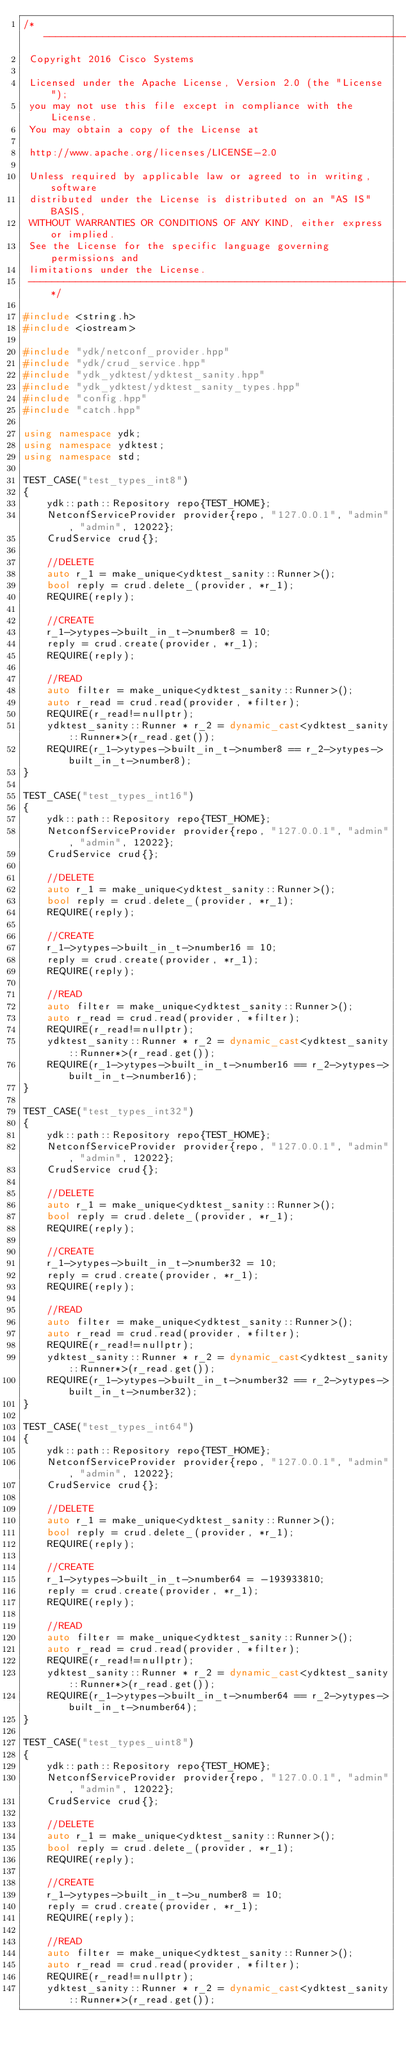Convert code to text. <code><loc_0><loc_0><loc_500><loc_500><_C++_>/*  ----------------------------------------------------------------
 Copyright 2016 Cisco Systems

 Licensed under the Apache License, Version 2.0 (the "License");
 you may not use this file except in compliance with the License.
 You may obtain a copy of the License at

 http://www.apache.org/licenses/LICENSE-2.0

 Unless required by applicable law or agreed to in writing, software
 distributed under the License is distributed on an "AS IS" BASIS,
 WITHOUT WARRANTIES OR CONDITIONS OF ANY KIND, either express or implied.
 See the License for the specific language governing permissions and
 limitations under the License.
 ------------------------------------------------------------------*/

#include <string.h>
#include <iostream>

#include "ydk/netconf_provider.hpp"
#include "ydk/crud_service.hpp"
#include "ydk_ydktest/ydktest_sanity.hpp"
#include "ydk_ydktest/ydktest_sanity_types.hpp"
#include "config.hpp"
#include "catch.hpp"

using namespace ydk;
using namespace ydktest;
using namespace std;

TEST_CASE("test_types_int8")
{
    ydk::path::Repository repo{TEST_HOME};
    NetconfServiceProvider provider{repo, "127.0.0.1", "admin", "admin", 12022};
    CrudService crud{};

    //DELETE
    auto r_1 = make_unique<ydktest_sanity::Runner>();
    bool reply = crud.delete_(provider, *r_1);
    REQUIRE(reply);

    //CREATE
    r_1->ytypes->built_in_t->number8 = 10;
    reply = crud.create(provider, *r_1);
    REQUIRE(reply);

    //READ
    auto filter = make_unique<ydktest_sanity::Runner>();
    auto r_read = crud.read(provider, *filter);
    REQUIRE(r_read!=nullptr);
    ydktest_sanity::Runner * r_2 = dynamic_cast<ydktest_sanity::Runner*>(r_read.get());
    REQUIRE(r_1->ytypes->built_in_t->number8 == r_2->ytypes->built_in_t->number8);
}

TEST_CASE("test_types_int16")
{
    ydk::path::Repository repo{TEST_HOME};
    NetconfServiceProvider provider{repo, "127.0.0.1", "admin", "admin", 12022};
    CrudService crud{};

    //DELETE
    auto r_1 = make_unique<ydktest_sanity::Runner>();
    bool reply = crud.delete_(provider, *r_1);
    REQUIRE(reply);

    //CREATE
    r_1->ytypes->built_in_t->number16 = 10;
    reply = crud.create(provider, *r_1);
    REQUIRE(reply);

    //READ
    auto filter = make_unique<ydktest_sanity::Runner>();
    auto r_read = crud.read(provider, *filter);
    REQUIRE(r_read!=nullptr);
    ydktest_sanity::Runner * r_2 = dynamic_cast<ydktest_sanity::Runner*>(r_read.get());
    REQUIRE(r_1->ytypes->built_in_t->number16 == r_2->ytypes->built_in_t->number16);
}

TEST_CASE("test_types_int32")
{
    ydk::path::Repository repo{TEST_HOME};
    NetconfServiceProvider provider{repo, "127.0.0.1", "admin", "admin", 12022};
    CrudService crud{};

    //DELETE
    auto r_1 = make_unique<ydktest_sanity::Runner>();
    bool reply = crud.delete_(provider, *r_1);
    REQUIRE(reply);

    //CREATE
    r_1->ytypes->built_in_t->number32 = 10;
    reply = crud.create(provider, *r_1);
    REQUIRE(reply);

    //READ
    auto filter = make_unique<ydktest_sanity::Runner>();
    auto r_read = crud.read(provider, *filter);
    REQUIRE(r_read!=nullptr);
    ydktest_sanity::Runner * r_2 = dynamic_cast<ydktest_sanity::Runner*>(r_read.get());
    REQUIRE(r_1->ytypes->built_in_t->number32 == r_2->ytypes->built_in_t->number32);
}

TEST_CASE("test_types_int64")
{
    ydk::path::Repository repo{TEST_HOME};
    NetconfServiceProvider provider{repo, "127.0.0.1", "admin", "admin", 12022};
    CrudService crud{};

    //DELETE
    auto r_1 = make_unique<ydktest_sanity::Runner>();
    bool reply = crud.delete_(provider, *r_1);
    REQUIRE(reply);

    //CREATE
    r_1->ytypes->built_in_t->number64 = -193933810;
    reply = crud.create(provider, *r_1);
    REQUIRE(reply);

    //READ
    auto filter = make_unique<ydktest_sanity::Runner>();
    auto r_read = crud.read(provider, *filter);
    REQUIRE(r_read!=nullptr);
    ydktest_sanity::Runner * r_2 = dynamic_cast<ydktest_sanity::Runner*>(r_read.get());
    REQUIRE(r_1->ytypes->built_in_t->number64 == r_2->ytypes->built_in_t->number64);
}

TEST_CASE("test_types_uint8")
{
    ydk::path::Repository repo{TEST_HOME};
    NetconfServiceProvider provider{repo, "127.0.0.1", "admin", "admin", 12022};
    CrudService crud{};

    //DELETE
    auto r_1 = make_unique<ydktest_sanity::Runner>();
    bool reply = crud.delete_(provider, *r_1);
    REQUIRE(reply);

    //CREATE
    r_1->ytypes->built_in_t->u_number8 = 10;
    reply = crud.create(provider, *r_1);
    REQUIRE(reply);

    //READ
    auto filter = make_unique<ydktest_sanity::Runner>();
    auto r_read = crud.read(provider, *filter);
    REQUIRE(r_read!=nullptr);
    ydktest_sanity::Runner * r_2 = dynamic_cast<ydktest_sanity::Runner*>(r_read.get());</code> 